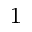<formula> <loc_0><loc_0><loc_500><loc_500>_ { 1 }</formula> 